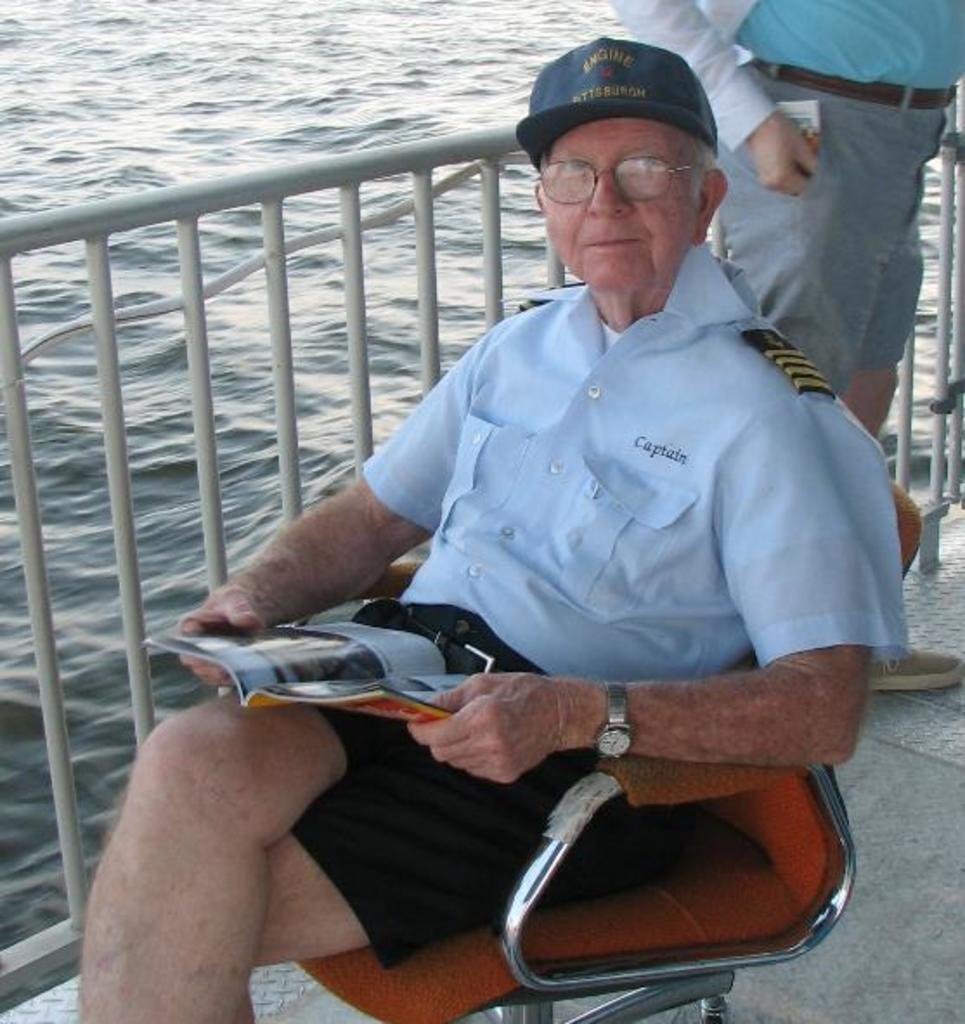In one or two sentences, can you explain what this image depicts? A person is sitting on a chair and holding a book. Backside of this person there is a another person standing beside this fence. Here we can see water. 